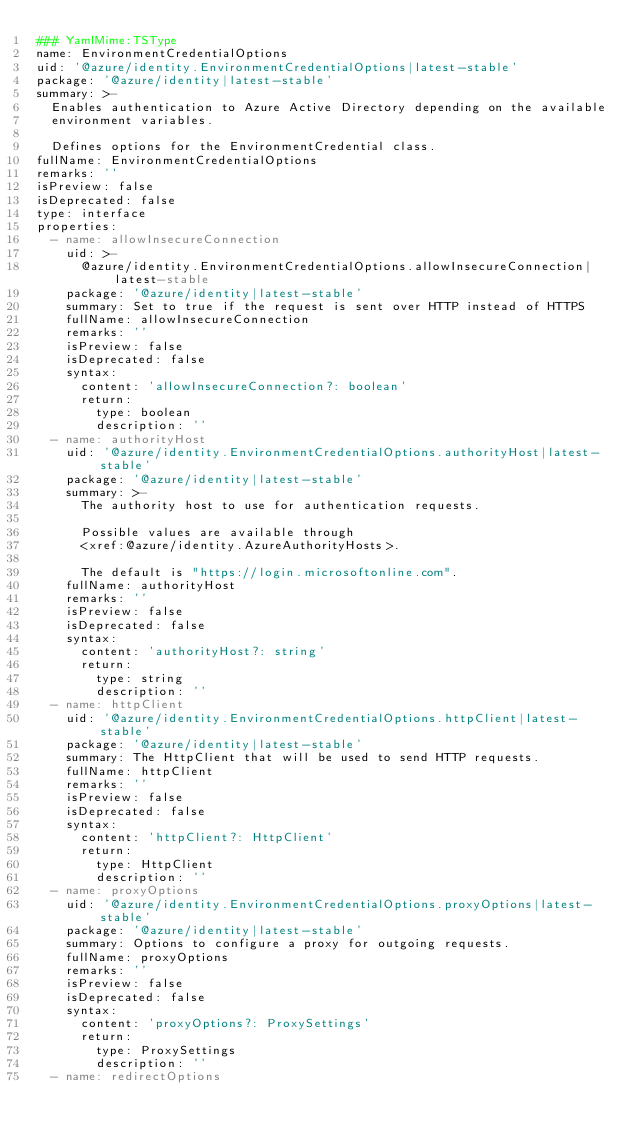<code> <loc_0><loc_0><loc_500><loc_500><_YAML_>### YamlMime:TSType
name: EnvironmentCredentialOptions
uid: '@azure/identity.EnvironmentCredentialOptions|latest-stable'
package: '@azure/identity|latest-stable'
summary: >-
  Enables authentication to Azure Active Directory depending on the available
  environment variables.

  Defines options for the EnvironmentCredential class.
fullName: EnvironmentCredentialOptions
remarks: ''
isPreview: false
isDeprecated: false
type: interface
properties:
  - name: allowInsecureConnection
    uid: >-
      @azure/identity.EnvironmentCredentialOptions.allowInsecureConnection|latest-stable
    package: '@azure/identity|latest-stable'
    summary: Set to true if the request is sent over HTTP instead of HTTPS
    fullName: allowInsecureConnection
    remarks: ''
    isPreview: false
    isDeprecated: false
    syntax:
      content: 'allowInsecureConnection?: boolean'
      return:
        type: boolean
        description: ''
  - name: authorityHost
    uid: '@azure/identity.EnvironmentCredentialOptions.authorityHost|latest-stable'
    package: '@azure/identity|latest-stable'
    summary: >-
      The authority host to use for authentication requests.

      Possible values are available through
      <xref:@azure/identity.AzureAuthorityHosts>.

      The default is "https://login.microsoftonline.com".
    fullName: authorityHost
    remarks: ''
    isPreview: false
    isDeprecated: false
    syntax:
      content: 'authorityHost?: string'
      return:
        type: string
        description: ''
  - name: httpClient
    uid: '@azure/identity.EnvironmentCredentialOptions.httpClient|latest-stable'
    package: '@azure/identity|latest-stable'
    summary: The HttpClient that will be used to send HTTP requests.
    fullName: httpClient
    remarks: ''
    isPreview: false
    isDeprecated: false
    syntax:
      content: 'httpClient?: HttpClient'
      return:
        type: HttpClient
        description: ''
  - name: proxyOptions
    uid: '@azure/identity.EnvironmentCredentialOptions.proxyOptions|latest-stable'
    package: '@azure/identity|latest-stable'
    summary: Options to configure a proxy for outgoing requests.
    fullName: proxyOptions
    remarks: ''
    isPreview: false
    isDeprecated: false
    syntax:
      content: 'proxyOptions?: ProxySettings'
      return:
        type: ProxySettings
        description: ''
  - name: redirectOptions</code> 